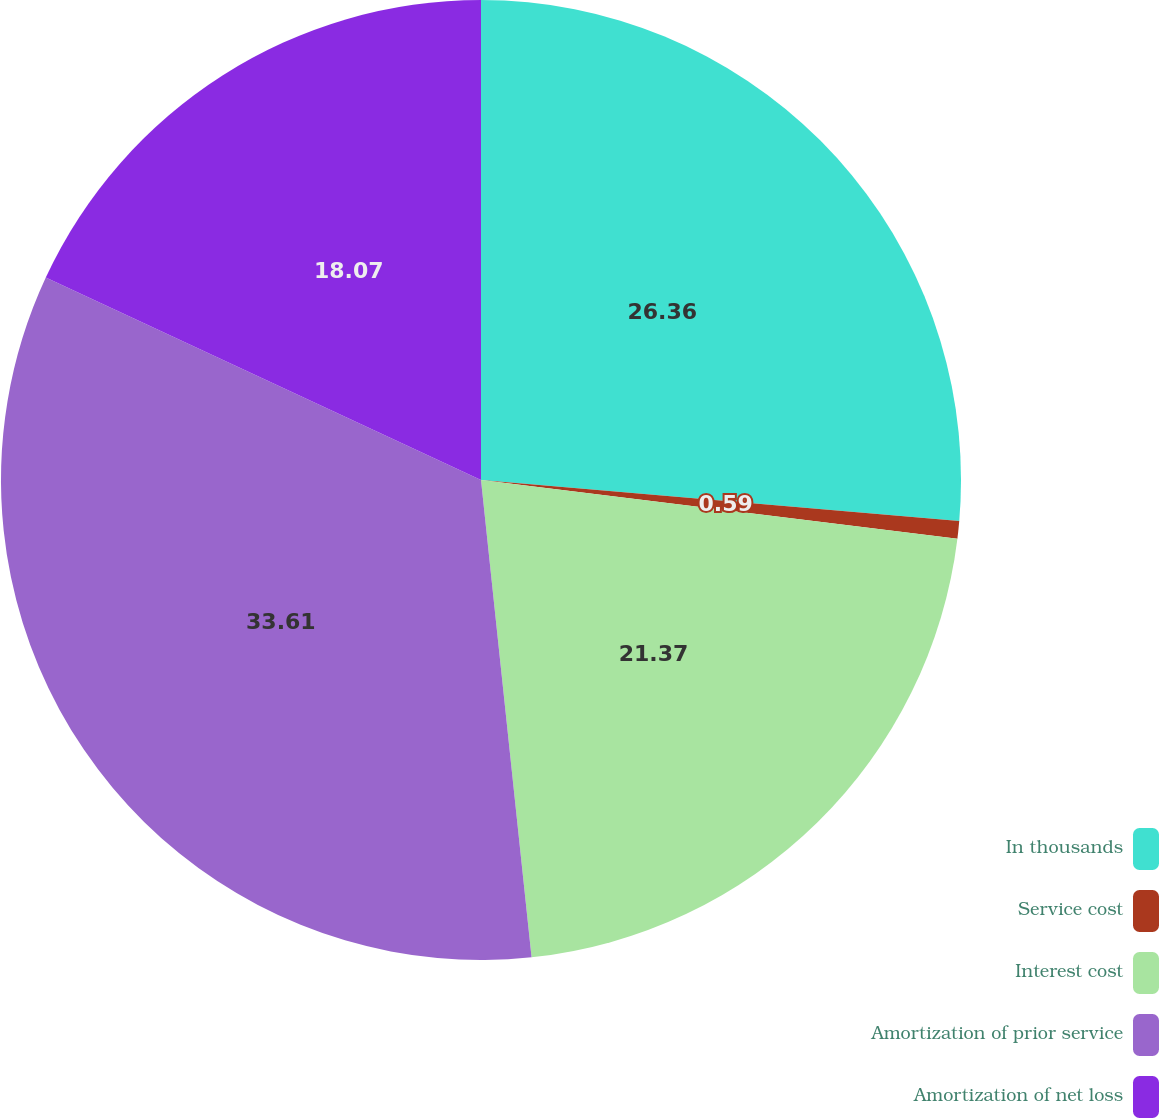Convert chart to OTSL. <chart><loc_0><loc_0><loc_500><loc_500><pie_chart><fcel>In thousands<fcel>Service cost<fcel>Interest cost<fcel>Amortization of prior service<fcel>Amortization of net loss<nl><fcel>26.36%<fcel>0.59%<fcel>21.37%<fcel>33.61%<fcel>18.07%<nl></chart> 